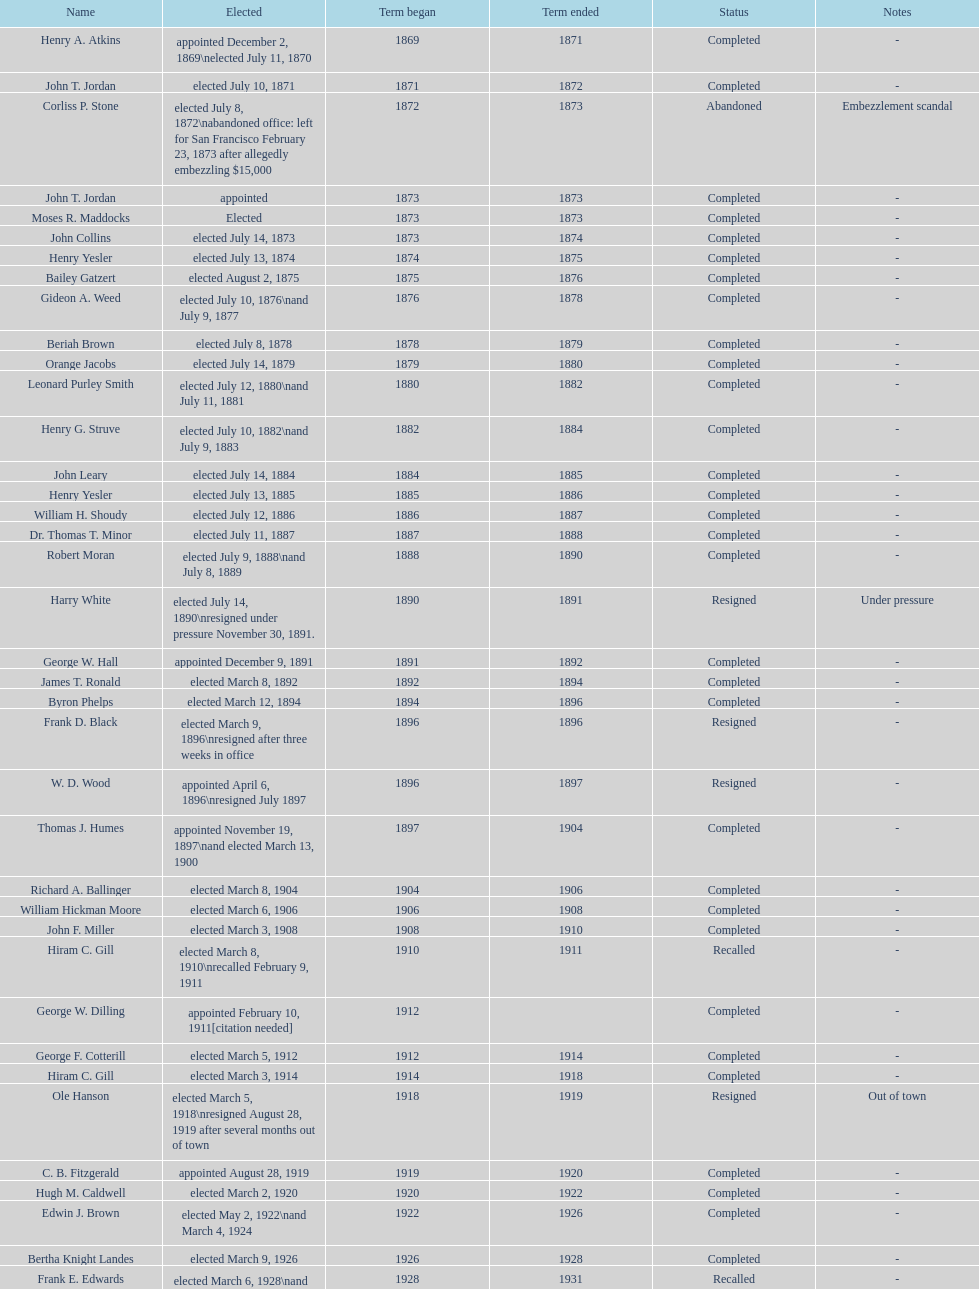Who was the mayor before jordan? Henry A. Atkins. 